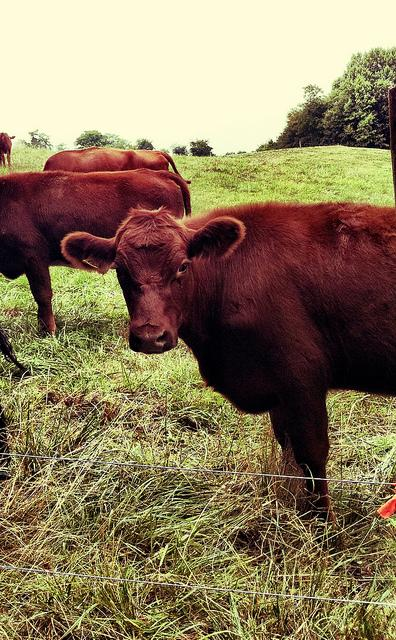What has the big ears? cow 